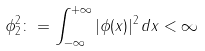<formula> <loc_0><loc_0><loc_500><loc_500>\| \phi \| _ { 2 } ^ { 2 } \colon = \int _ { - \infty } ^ { + \infty } | \phi ( x ) | ^ { 2 } \, d x < \infty</formula> 